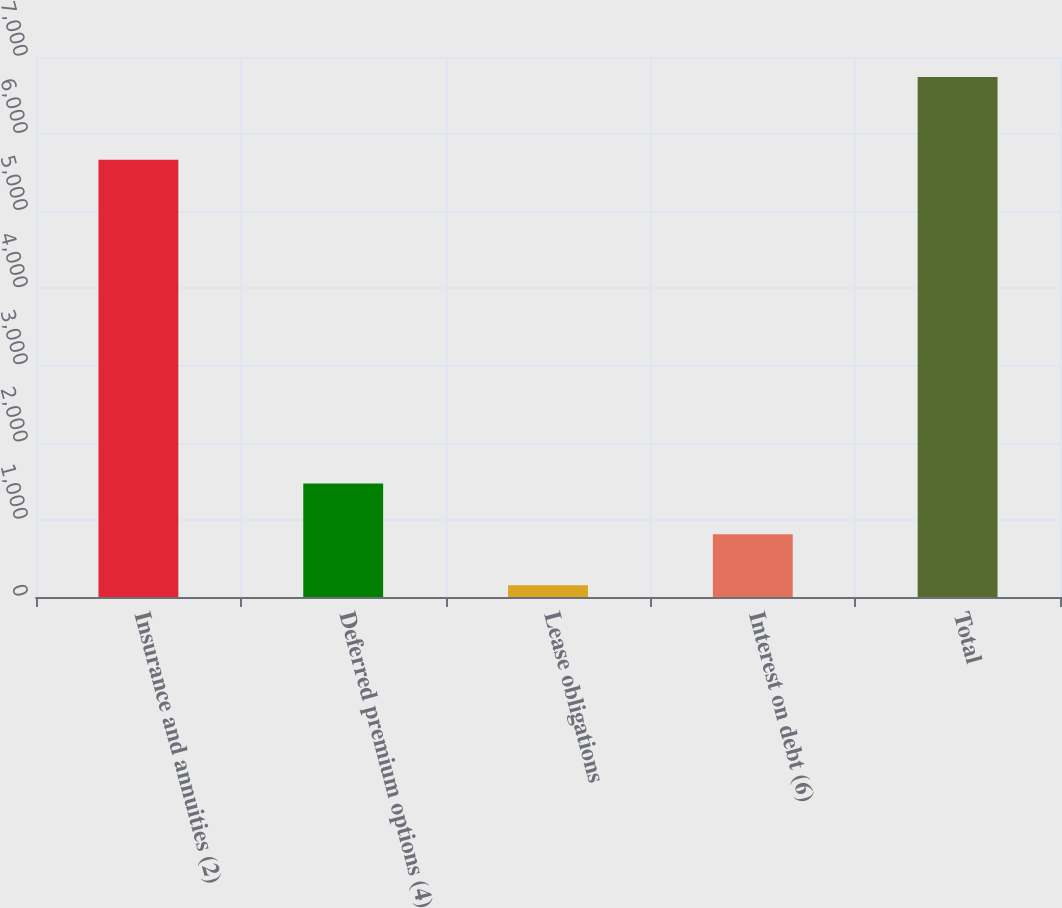Convert chart. <chart><loc_0><loc_0><loc_500><loc_500><bar_chart><fcel>Insurance and annuities (2)<fcel>Deferred premium options (4)<fcel>Lease obligations<fcel>Interest on debt (6)<fcel>Total<nl><fcel>5668<fcel>1470.8<fcel>153<fcel>811.9<fcel>6742<nl></chart> 